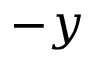Convert formula to latex. <formula><loc_0><loc_0><loc_500><loc_500>- y</formula> 